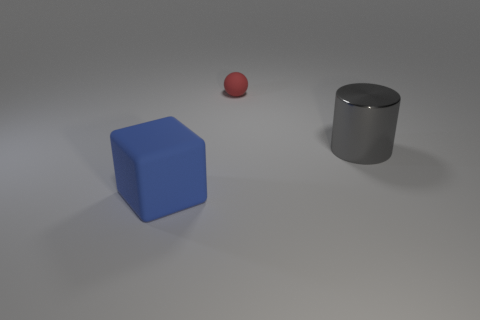The thing that is in front of the big object that is to the right of the small rubber sphere is what shape?
Your response must be concise. Cube. Is there any other thing that is the same shape as the large gray metallic thing?
Ensure brevity in your answer.  No. Are there the same number of tiny red objects to the right of the gray shiny object and gray metallic spheres?
Your answer should be compact. Yes. There is a large cylinder; does it have the same color as the thing that is to the left of the tiny red ball?
Provide a succinct answer. No. The object that is both to the left of the large gray cylinder and to the right of the big blue thing is what color?
Offer a terse response. Red. How many cylinders are behind the rubber thing that is in front of the small matte ball?
Ensure brevity in your answer.  1. Is there a metal object of the same shape as the large matte thing?
Keep it short and to the point. No. Do the large thing on the left side of the big metal thing and the thing on the right side of the tiny red rubber sphere have the same shape?
Give a very brief answer. No. What number of objects are either cubes or large gray things?
Your response must be concise. 2. Are there more tiny balls in front of the red sphere than large blue rubber cubes?
Give a very brief answer. No. 